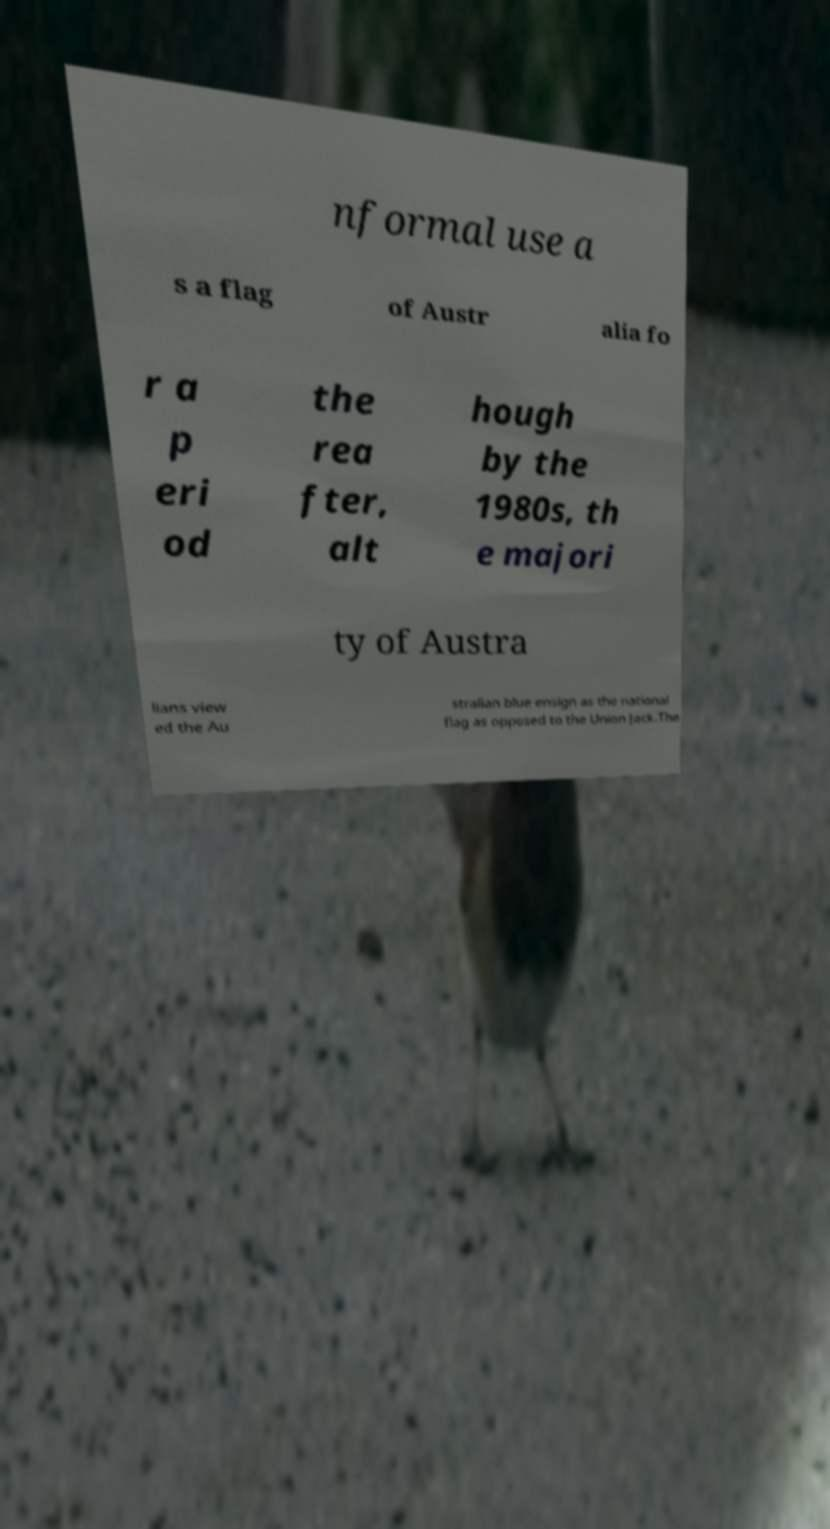What messages or text are displayed in this image? I need them in a readable, typed format. nformal use a s a flag of Austr alia fo r a p eri od the rea fter, alt hough by the 1980s, th e majori ty of Austra lians view ed the Au stralian blue ensign as the national flag as opposed to the Union Jack.The 